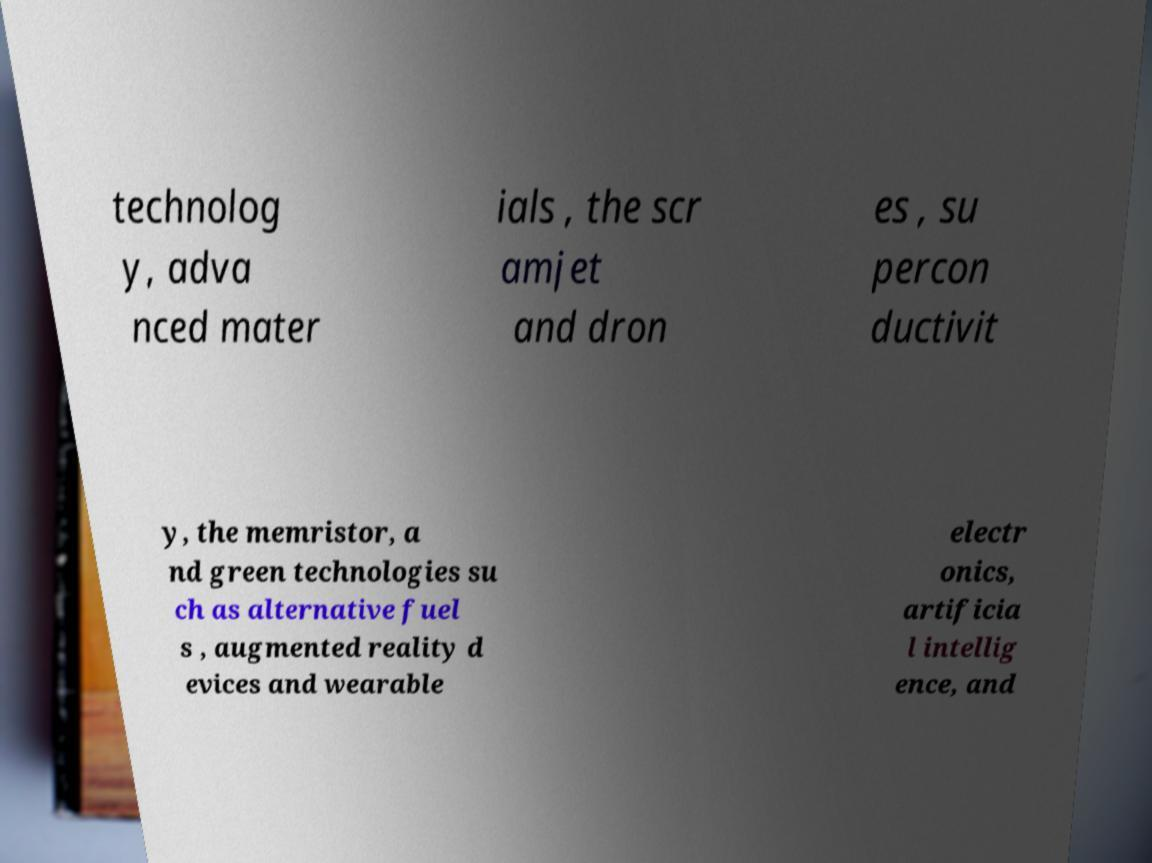Can you accurately transcribe the text from the provided image for me? technolog y, adva nced mater ials , the scr amjet and dron es , su percon ductivit y, the memristor, a nd green technologies su ch as alternative fuel s , augmented reality d evices and wearable electr onics, artificia l intellig ence, and 